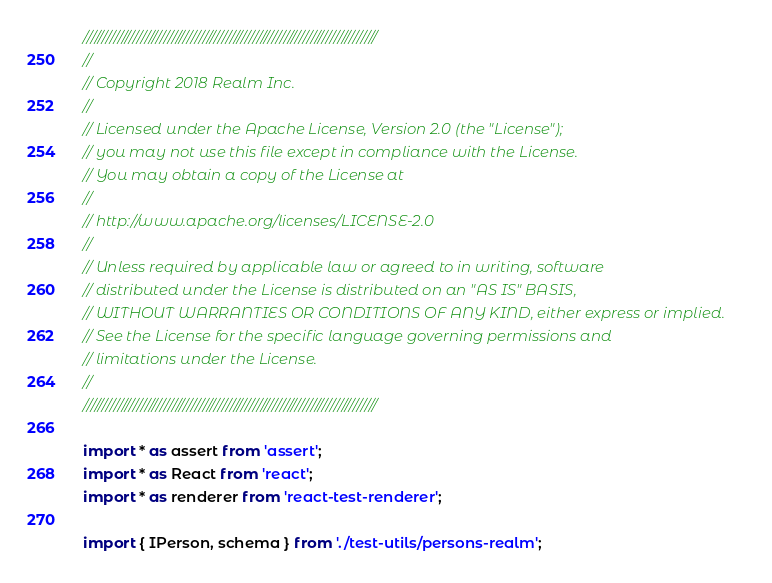<code> <loc_0><loc_0><loc_500><loc_500><_TypeScript_>////////////////////////////////////////////////////////////////////////////
//
// Copyright 2018 Realm Inc.
//
// Licensed under the Apache License, Version 2.0 (the "License");
// you may not use this file except in compliance with the License.
// You may obtain a copy of the License at
//
// http://www.apache.org/licenses/LICENSE-2.0
//
// Unless required by applicable law or agreed to in writing, software
// distributed under the License is distributed on an "AS IS" BASIS,
// WITHOUT WARRANTIES OR CONDITIONS OF ANY KIND, either express or implied.
// See the License for the specific language governing permissions and
// limitations under the License.
//
////////////////////////////////////////////////////////////////////////////

import * as assert from 'assert';
import * as React from 'react';
import * as renderer from 'react-test-renderer';

import { IPerson, schema } from './test-utils/persons-realm';
</code> 